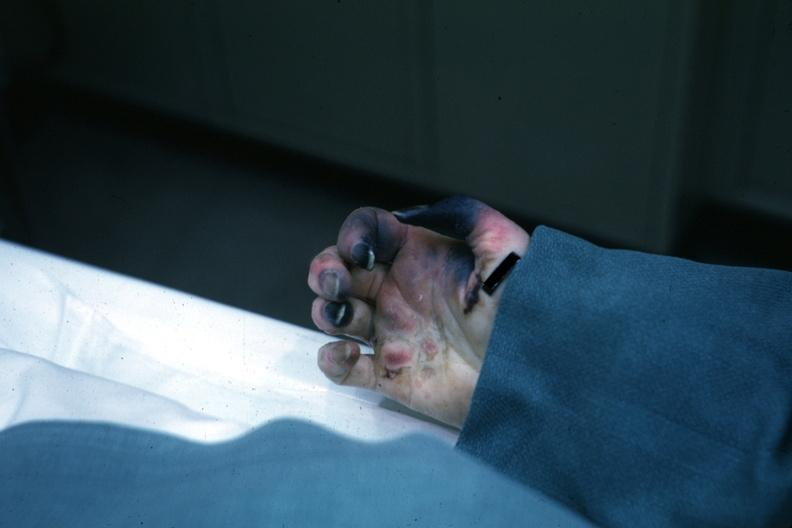does notochord show obvious gangrenous necrosis child with congenital heart disease post op exact cause not know shock vs emboli?
Answer the question using a single word or phrase. No 